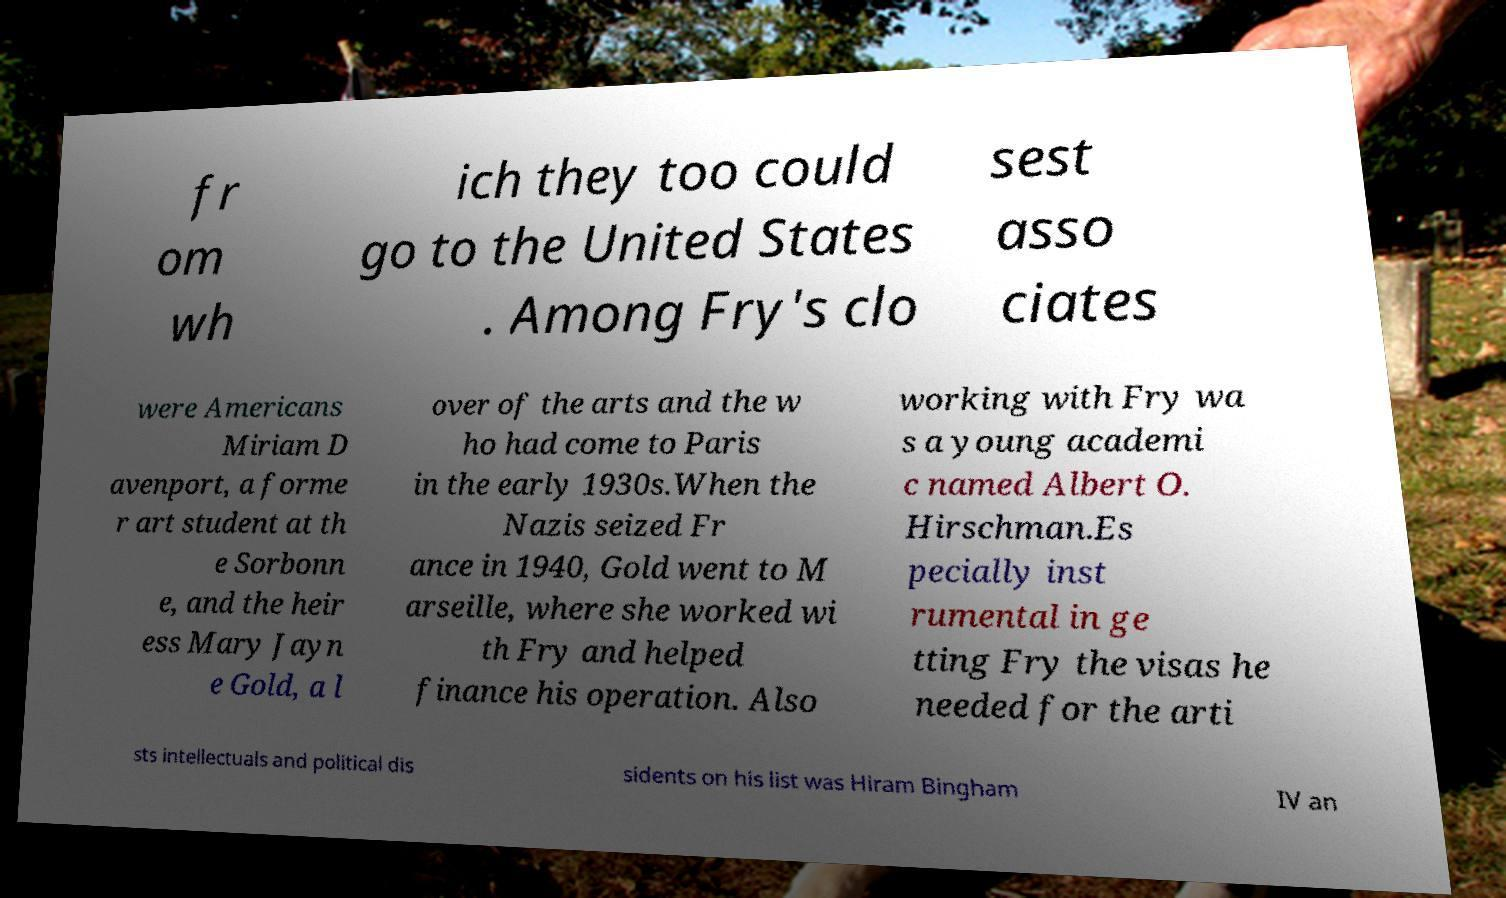Please read and relay the text visible in this image. What does it say? fr om wh ich they too could go to the United States . Among Fry's clo sest asso ciates were Americans Miriam D avenport, a forme r art student at th e Sorbonn e, and the heir ess Mary Jayn e Gold, a l over of the arts and the w ho had come to Paris in the early 1930s.When the Nazis seized Fr ance in 1940, Gold went to M arseille, where she worked wi th Fry and helped finance his operation. Also working with Fry wa s a young academi c named Albert O. Hirschman.Es pecially inst rumental in ge tting Fry the visas he needed for the arti sts intellectuals and political dis sidents on his list was Hiram Bingham IV an 